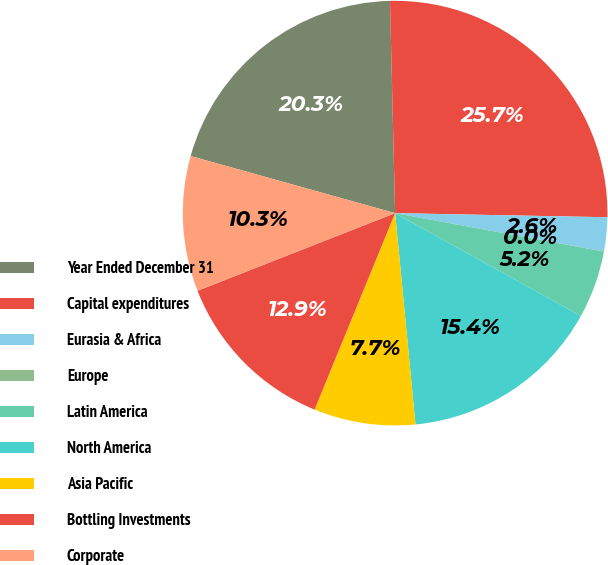Convert chart. <chart><loc_0><loc_0><loc_500><loc_500><pie_chart><fcel>Year Ended December 31<fcel>Capital expenditures<fcel>Eurasia & Africa<fcel>Europe<fcel>Latin America<fcel>North America<fcel>Asia Pacific<fcel>Bottling Investments<fcel>Corporate<nl><fcel>20.28%<fcel>25.69%<fcel>2.58%<fcel>0.01%<fcel>5.15%<fcel>15.42%<fcel>7.72%<fcel>12.85%<fcel>10.29%<nl></chart> 